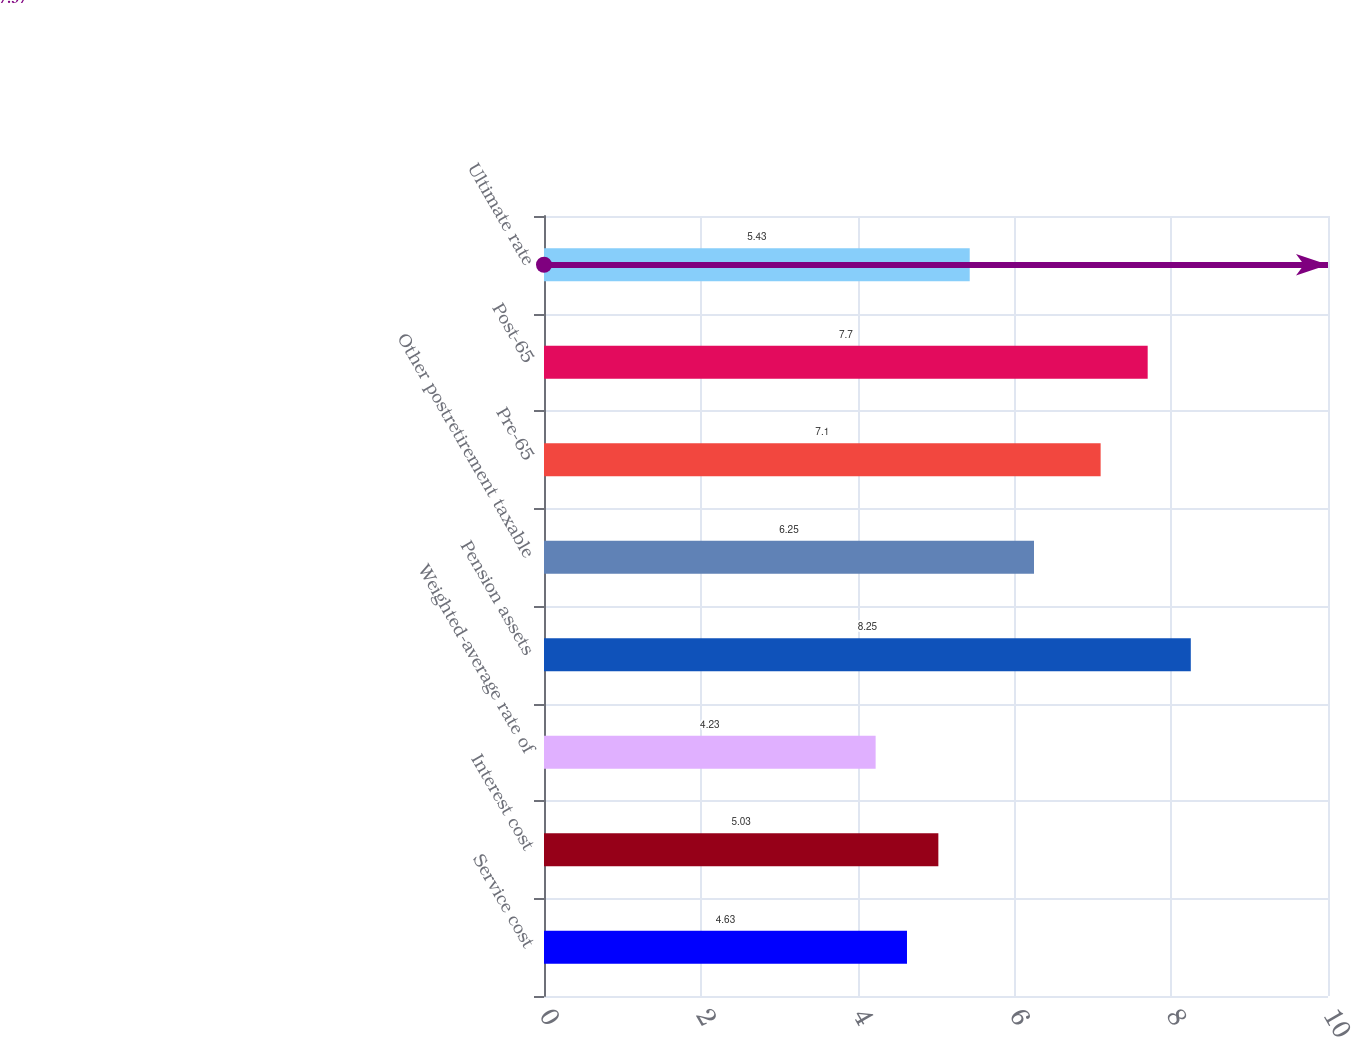Convert chart. <chart><loc_0><loc_0><loc_500><loc_500><bar_chart><fcel>Service cost<fcel>Interest cost<fcel>Weighted-average rate of<fcel>Pension assets<fcel>Other postretirement taxable<fcel>Pre-65<fcel>Post-65<fcel>Ultimate rate<nl><fcel>4.63<fcel>5.03<fcel>4.23<fcel>8.25<fcel>6.25<fcel>7.1<fcel>7.7<fcel>5.43<nl></chart> 